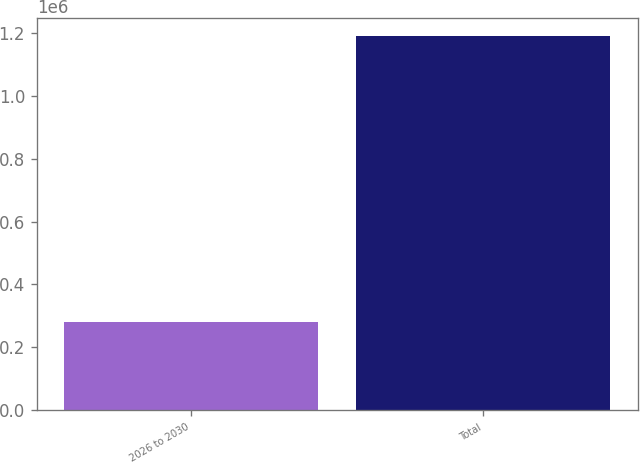Convert chart to OTSL. <chart><loc_0><loc_0><loc_500><loc_500><bar_chart><fcel>2026 to 2030<fcel>Total<nl><fcel>279908<fcel>1.188e+06<nl></chart> 